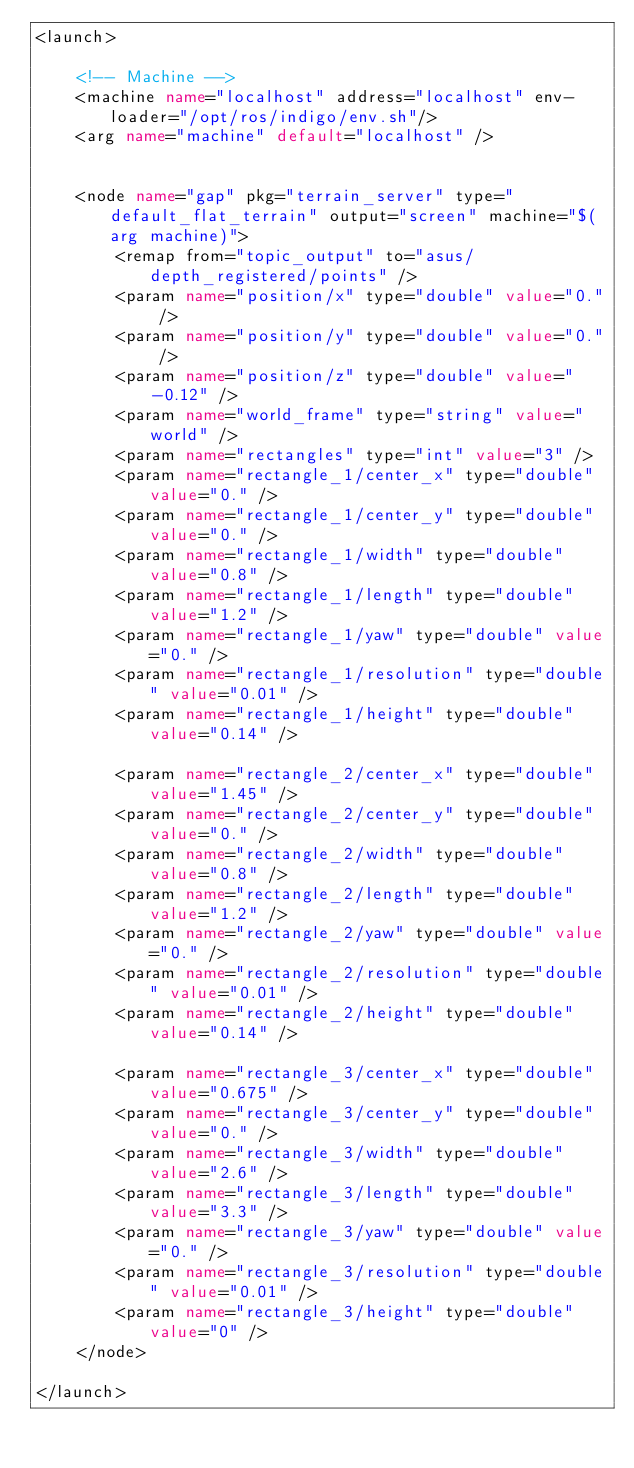<code> <loc_0><loc_0><loc_500><loc_500><_XML_><launch>

	<!-- Machine -->
	<machine name="localhost" address="localhost" env-loader="/opt/ros/indigo/env.sh"/>
	<arg name="machine" default="localhost" />


	<node name="gap" pkg="terrain_server" type="default_flat_terrain" output="screen" machine="$(arg machine)">
		<remap from="topic_output" to="asus/depth_registered/points" />
		<param name="position/x" type="double" value="0." />
		<param name="position/y" type="double" value="0." />
		<param name="position/z" type="double" value="-0.12" />
		<param name="world_frame" type="string" value="world" />
		<param name="rectangles" type="int" value="3" />
		<param name="rectangle_1/center_x" type="double" value="0." />
		<param name="rectangle_1/center_y" type="double" value="0." />
		<param name="rectangle_1/width" type="double" value="0.8" />
		<param name="rectangle_1/length" type="double" value="1.2" />
		<param name="rectangle_1/yaw" type="double" value="0." />
		<param name="rectangle_1/resolution" type="double" value="0.01" />
		<param name="rectangle_1/height" type="double" value="0.14" />

		<param name="rectangle_2/center_x" type="double" value="1.45" />
		<param name="rectangle_2/center_y" type="double" value="0." />
		<param name="rectangle_2/width" type="double" value="0.8" />
		<param name="rectangle_2/length" type="double" value="1.2" />
		<param name="rectangle_2/yaw" type="double" value="0." />
		<param name="rectangle_2/resolution" type="double" value="0.01" />
		<param name="rectangle_2/height" type="double" value="0.14" />

		<param name="rectangle_3/center_x" type="double" value="0.675" />
		<param name="rectangle_3/center_y" type="double" value="0." />
		<param name="rectangle_3/width" type="double" value="2.6" />
		<param name="rectangle_3/length" type="double" value="3.3" />
		<param name="rectangle_3/yaw" type="double" value="0." />
		<param name="rectangle_3/resolution" type="double" value="0.01" />
		<param name="rectangle_3/height" type="double" value="0" />
	</node>

</launch>
</code> 